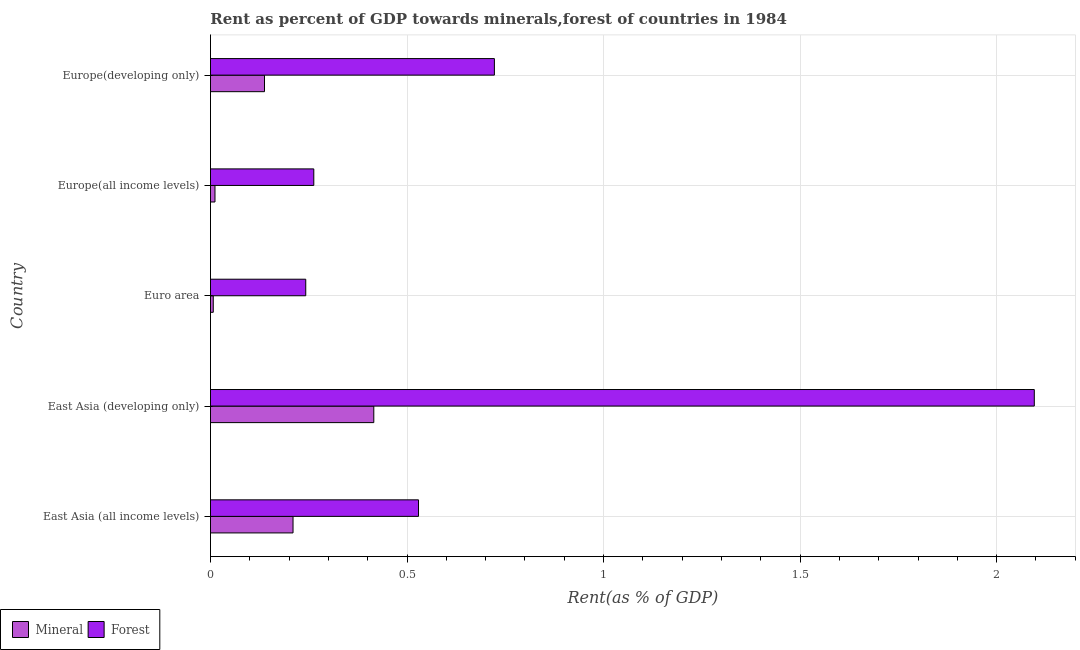How many groups of bars are there?
Offer a terse response. 5. How many bars are there on the 2nd tick from the bottom?
Provide a short and direct response. 2. What is the mineral rent in East Asia (developing only)?
Offer a terse response. 0.42. Across all countries, what is the maximum forest rent?
Your response must be concise. 2.1. Across all countries, what is the minimum mineral rent?
Ensure brevity in your answer.  0.01. In which country was the mineral rent maximum?
Offer a very short reply. East Asia (developing only). What is the total forest rent in the graph?
Your response must be concise. 3.85. What is the difference between the mineral rent in East Asia (developing only) and that in Euro area?
Offer a very short reply. 0.41. What is the difference between the forest rent in Europe(all income levels) and the mineral rent in East Asia (developing only)?
Your answer should be very brief. -0.15. What is the average mineral rent per country?
Provide a succinct answer. 0.16. What is the difference between the mineral rent and forest rent in East Asia (developing only)?
Your answer should be compact. -1.68. What is the ratio of the forest rent in East Asia (all income levels) to that in Euro area?
Keep it short and to the point. 2.18. What is the difference between the highest and the second highest forest rent?
Provide a short and direct response. 1.37. What is the difference between the highest and the lowest mineral rent?
Offer a terse response. 0.41. Is the sum of the forest rent in East Asia (all income levels) and Europe(all income levels) greater than the maximum mineral rent across all countries?
Provide a succinct answer. Yes. What does the 2nd bar from the top in Europe(all income levels) represents?
Provide a short and direct response. Mineral. What does the 1st bar from the bottom in East Asia (developing only) represents?
Ensure brevity in your answer.  Mineral. How many bars are there?
Provide a succinct answer. 10. Where does the legend appear in the graph?
Your answer should be very brief. Bottom left. How many legend labels are there?
Provide a short and direct response. 2. How are the legend labels stacked?
Your response must be concise. Horizontal. What is the title of the graph?
Give a very brief answer. Rent as percent of GDP towards minerals,forest of countries in 1984. Does "Female" appear as one of the legend labels in the graph?
Your answer should be very brief. No. What is the label or title of the X-axis?
Offer a terse response. Rent(as % of GDP). What is the label or title of the Y-axis?
Your response must be concise. Country. What is the Rent(as % of GDP) of Mineral in East Asia (all income levels)?
Your answer should be very brief. 0.21. What is the Rent(as % of GDP) in Forest in East Asia (all income levels)?
Make the answer very short. 0.53. What is the Rent(as % of GDP) of Mineral in East Asia (developing only)?
Your answer should be very brief. 0.42. What is the Rent(as % of GDP) of Forest in East Asia (developing only)?
Make the answer very short. 2.1. What is the Rent(as % of GDP) in Mineral in Euro area?
Make the answer very short. 0.01. What is the Rent(as % of GDP) of Forest in Euro area?
Ensure brevity in your answer.  0.24. What is the Rent(as % of GDP) of Mineral in Europe(all income levels)?
Offer a terse response. 0.01. What is the Rent(as % of GDP) in Forest in Europe(all income levels)?
Ensure brevity in your answer.  0.26. What is the Rent(as % of GDP) of Mineral in Europe(developing only)?
Your response must be concise. 0.14. What is the Rent(as % of GDP) of Forest in Europe(developing only)?
Your answer should be compact. 0.72. Across all countries, what is the maximum Rent(as % of GDP) in Mineral?
Offer a terse response. 0.42. Across all countries, what is the maximum Rent(as % of GDP) of Forest?
Give a very brief answer. 2.1. Across all countries, what is the minimum Rent(as % of GDP) of Mineral?
Your response must be concise. 0.01. Across all countries, what is the minimum Rent(as % of GDP) of Forest?
Provide a succinct answer. 0.24. What is the total Rent(as % of GDP) of Mineral in the graph?
Give a very brief answer. 0.78. What is the total Rent(as % of GDP) in Forest in the graph?
Your answer should be very brief. 3.85. What is the difference between the Rent(as % of GDP) in Mineral in East Asia (all income levels) and that in East Asia (developing only)?
Your answer should be very brief. -0.21. What is the difference between the Rent(as % of GDP) of Forest in East Asia (all income levels) and that in East Asia (developing only)?
Provide a short and direct response. -1.57. What is the difference between the Rent(as % of GDP) of Mineral in East Asia (all income levels) and that in Euro area?
Your answer should be very brief. 0.2. What is the difference between the Rent(as % of GDP) of Forest in East Asia (all income levels) and that in Euro area?
Make the answer very short. 0.29. What is the difference between the Rent(as % of GDP) of Mineral in East Asia (all income levels) and that in Europe(all income levels)?
Ensure brevity in your answer.  0.2. What is the difference between the Rent(as % of GDP) of Forest in East Asia (all income levels) and that in Europe(all income levels)?
Your answer should be compact. 0.27. What is the difference between the Rent(as % of GDP) in Mineral in East Asia (all income levels) and that in Europe(developing only)?
Offer a terse response. 0.07. What is the difference between the Rent(as % of GDP) in Forest in East Asia (all income levels) and that in Europe(developing only)?
Make the answer very short. -0.19. What is the difference between the Rent(as % of GDP) of Mineral in East Asia (developing only) and that in Euro area?
Your answer should be compact. 0.41. What is the difference between the Rent(as % of GDP) in Forest in East Asia (developing only) and that in Euro area?
Ensure brevity in your answer.  1.85. What is the difference between the Rent(as % of GDP) of Mineral in East Asia (developing only) and that in Europe(all income levels)?
Make the answer very short. 0.4. What is the difference between the Rent(as % of GDP) in Forest in East Asia (developing only) and that in Europe(all income levels)?
Offer a terse response. 1.83. What is the difference between the Rent(as % of GDP) of Mineral in East Asia (developing only) and that in Europe(developing only)?
Keep it short and to the point. 0.28. What is the difference between the Rent(as % of GDP) of Forest in East Asia (developing only) and that in Europe(developing only)?
Your answer should be very brief. 1.37. What is the difference between the Rent(as % of GDP) of Mineral in Euro area and that in Europe(all income levels)?
Give a very brief answer. -0. What is the difference between the Rent(as % of GDP) in Forest in Euro area and that in Europe(all income levels)?
Your answer should be compact. -0.02. What is the difference between the Rent(as % of GDP) of Mineral in Euro area and that in Europe(developing only)?
Your response must be concise. -0.13. What is the difference between the Rent(as % of GDP) of Forest in Euro area and that in Europe(developing only)?
Provide a short and direct response. -0.48. What is the difference between the Rent(as % of GDP) of Mineral in Europe(all income levels) and that in Europe(developing only)?
Provide a short and direct response. -0.13. What is the difference between the Rent(as % of GDP) in Forest in Europe(all income levels) and that in Europe(developing only)?
Your response must be concise. -0.46. What is the difference between the Rent(as % of GDP) in Mineral in East Asia (all income levels) and the Rent(as % of GDP) in Forest in East Asia (developing only)?
Offer a terse response. -1.89. What is the difference between the Rent(as % of GDP) of Mineral in East Asia (all income levels) and the Rent(as % of GDP) of Forest in Euro area?
Your answer should be very brief. -0.03. What is the difference between the Rent(as % of GDP) of Mineral in East Asia (all income levels) and the Rent(as % of GDP) of Forest in Europe(all income levels)?
Offer a very short reply. -0.05. What is the difference between the Rent(as % of GDP) of Mineral in East Asia (all income levels) and the Rent(as % of GDP) of Forest in Europe(developing only)?
Your answer should be compact. -0.51. What is the difference between the Rent(as % of GDP) of Mineral in East Asia (developing only) and the Rent(as % of GDP) of Forest in Euro area?
Offer a very short reply. 0.17. What is the difference between the Rent(as % of GDP) of Mineral in East Asia (developing only) and the Rent(as % of GDP) of Forest in Europe(all income levels)?
Your response must be concise. 0.15. What is the difference between the Rent(as % of GDP) of Mineral in East Asia (developing only) and the Rent(as % of GDP) of Forest in Europe(developing only)?
Provide a succinct answer. -0.31. What is the difference between the Rent(as % of GDP) in Mineral in Euro area and the Rent(as % of GDP) in Forest in Europe(all income levels)?
Ensure brevity in your answer.  -0.26. What is the difference between the Rent(as % of GDP) of Mineral in Euro area and the Rent(as % of GDP) of Forest in Europe(developing only)?
Offer a terse response. -0.72. What is the difference between the Rent(as % of GDP) of Mineral in Europe(all income levels) and the Rent(as % of GDP) of Forest in Europe(developing only)?
Ensure brevity in your answer.  -0.71. What is the average Rent(as % of GDP) in Mineral per country?
Offer a very short reply. 0.16. What is the average Rent(as % of GDP) of Forest per country?
Ensure brevity in your answer.  0.77. What is the difference between the Rent(as % of GDP) of Mineral and Rent(as % of GDP) of Forest in East Asia (all income levels)?
Make the answer very short. -0.32. What is the difference between the Rent(as % of GDP) in Mineral and Rent(as % of GDP) in Forest in East Asia (developing only)?
Offer a very short reply. -1.68. What is the difference between the Rent(as % of GDP) of Mineral and Rent(as % of GDP) of Forest in Euro area?
Give a very brief answer. -0.24. What is the difference between the Rent(as % of GDP) in Mineral and Rent(as % of GDP) in Forest in Europe(all income levels)?
Offer a terse response. -0.25. What is the difference between the Rent(as % of GDP) in Mineral and Rent(as % of GDP) in Forest in Europe(developing only)?
Ensure brevity in your answer.  -0.58. What is the ratio of the Rent(as % of GDP) of Mineral in East Asia (all income levels) to that in East Asia (developing only)?
Make the answer very short. 0.51. What is the ratio of the Rent(as % of GDP) in Forest in East Asia (all income levels) to that in East Asia (developing only)?
Provide a short and direct response. 0.25. What is the ratio of the Rent(as % of GDP) of Mineral in East Asia (all income levels) to that in Euro area?
Give a very brief answer. 29.51. What is the ratio of the Rent(as % of GDP) in Forest in East Asia (all income levels) to that in Euro area?
Offer a terse response. 2.18. What is the ratio of the Rent(as % of GDP) of Mineral in East Asia (all income levels) to that in Europe(all income levels)?
Your response must be concise. 18.32. What is the ratio of the Rent(as % of GDP) in Forest in East Asia (all income levels) to that in Europe(all income levels)?
Your answer should be compact. 2.01. What is the ratio of the Rent(as % of GDP) of Mineral in East Asia (all income levels) to that in Europe(developing only)?
Ensure brevity in your answer.  1.53. What is the ratio of the Rent(as % of GDP) in Forest in East Asia (all income levels) to that in Europe(developing only)?
Offer a very short reply. 0.73. What is the ratio of the Rent(as % of GDP) in Mineral in East Asia (developing only) to that in Euro area?
Offer a terse response. 58.37. What is the ratio of the Rent(as % of GDP) in Forest in East Asia (developing only) to that in Euro area?
Your answer should be very brief. 8.65. What is the ratio of the Rent(as % of GDP) of Mineral in East Asia (developing only) to that in Europe(all income levels)?
Ensure brevity in your answer.  36.25. What is the ratio of the Rent(as % of GDP) of Forest in East Asia (developing only) to that in Europe(all income levels)?
Provide a succinct answer. 7.97. What is the ratio of the Rent(as % of GDP) in Mineral in East Asia (developing only) to that in Europe(developing only)?
Give a very brief answer. 3.02. What is the ratio of the Rent(as % of GDP) in Forest in East Asia (developing only) to that in Europe(developing only)?
Make the answer very short. 2.9. What is the ratio of the Rent(as % of GDP) in Mineral in Euro area to that in Europe(all income levels)?
Offer a very short reply. 0.62. What is the ratio of the Rent(as % of GDP) of Forest in Euro area to that in Europe(all income levels)?
Your answer should be very brief. 0.92. What is the ratio of the Rent(as % of GDP) of Mineral in Euro area to that in Europe(developing only)?
Provide a short and direct response. 0.05. What is the ratio of the Rent(as % of GDP) in Forest in Euro area to that in Europe(developing only)?
Keep it short and to the point. 0.34. What is the ratio of the Rent(as % of GDP) of Mineral in Europe(all income levels) to that in Europe(developing only)?
Your answer should be compact. 0.08. What is the ratio of the Rent(as % of GDP) of Forest in Europe(all income levels) to that in Europe(developing only)?
Your answer should be compact. 0.36. What is the difference between the highest and the second highest Rent(as % of GDP) in Mineral?
Your response must be concise. 0.21. What is the difference between the highest and the second highest Rent(as % of GDP) in Forest?
Your answer should be very brief. 1.37. What is the difference between the highest and the lowest Rent(as % of GDP) of Mineral?
Your answer should be very brief. 0.41. What is the difference between the highest and the lowest Rent(as % of GDP) of Forest?
Make the answer very short. 1.85. 